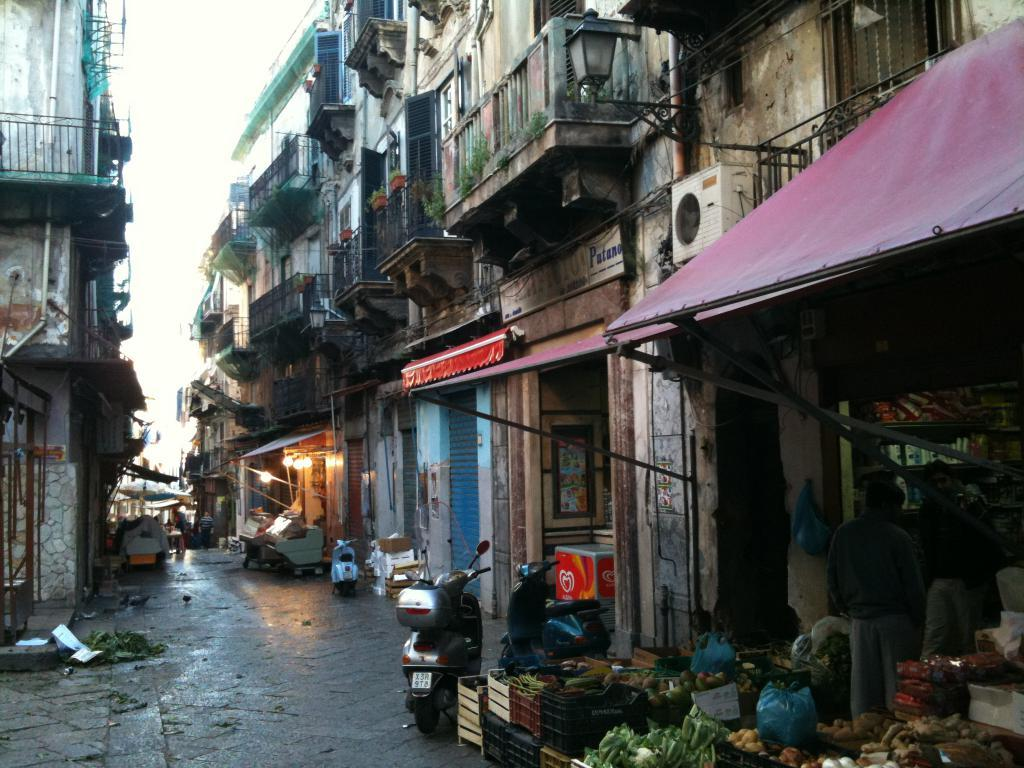What type of structures can be seen in the image? There are buildings in the image. What else is visible in the image besides the buildings? There are lights, trees, vegetables, and baskets in the image. What can be seen in the sky in the image? The sky is visible in the image. Where are the children playing with marbles in the image? There are no children or marbles present in the image. 